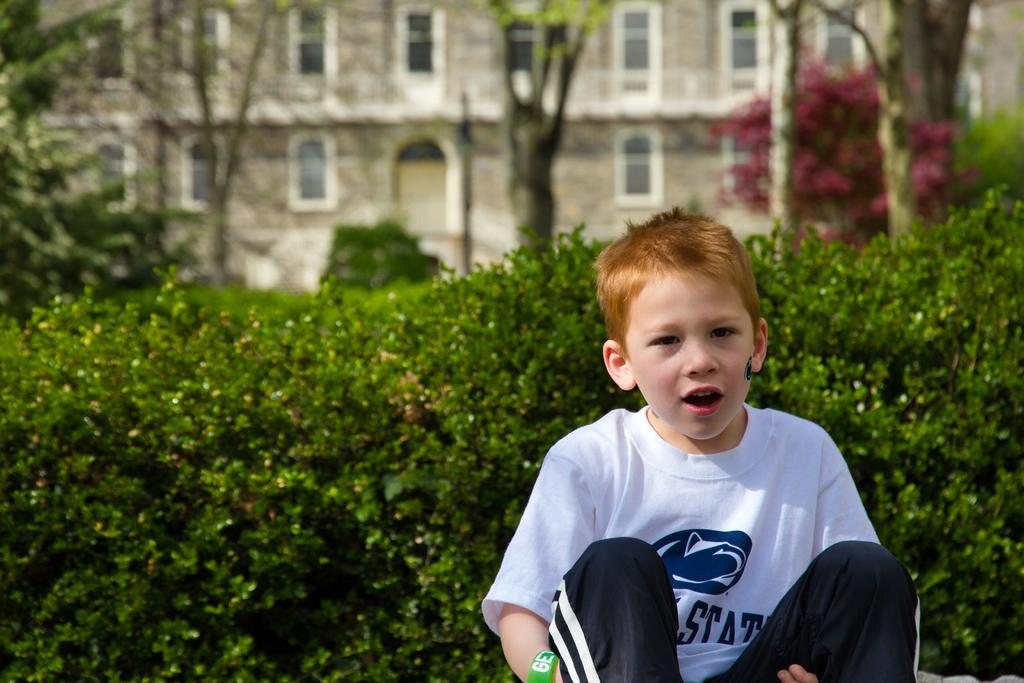<image>
Create a compact narrative representing the image presented. Boy with red hair wearing a State shirt sitting on the grass. 